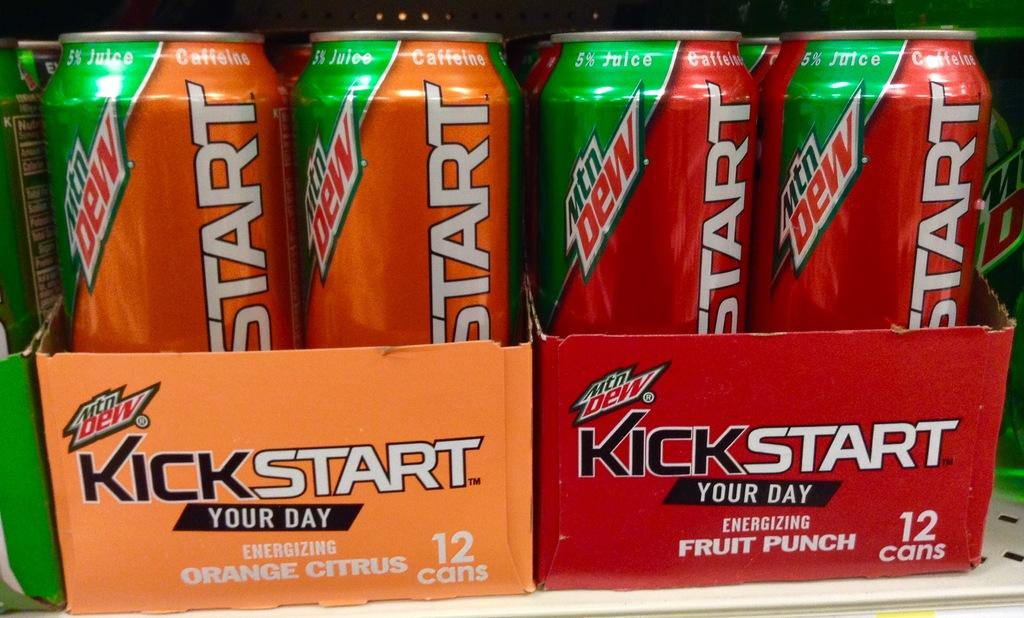<image>
Give a short and clear explanation of the subsequent image. a kick start package that is next to another one 